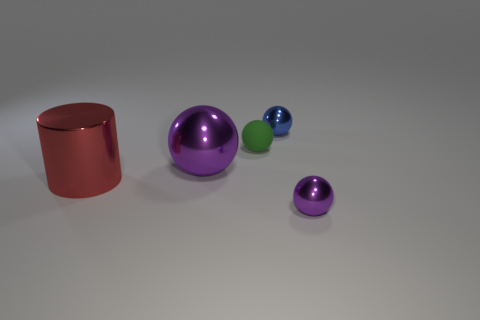Subtract all big purple metallic balls. How many balls are left? 3 Subtract all gray cylinders. How many purple balls are left? 2 Add 4 red shiny cylinders. How many objects exist? 9 Subtract all blue spheres. How many spheres are left? 3 Subtract 1 balls. How many balls are left? 3 Subtract all balls. How many objects are left? 1 Subtract all yellow cylinders. Subtract all purple blocks. How many cylinders are left? 1 Subtract all large spheres. Subtract all tiny blue things. How many objects are left? 3 Add 4 purple spheres. How many purple spheres are left? 6 Add 3 tiny cyan spheres. How many tiny cyan spheres exist? 3 